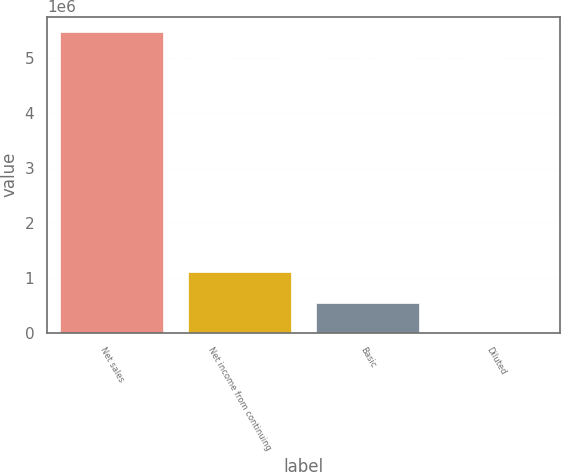Convert chart. <chart><loc_0><loc_0><loc_500><loc_500><bar_chart><fcel>Net sales<fcel>Net income from continuing<fcel>Basic<fcel>Diluted<nl><fcel>5.49086e+06<fcel>1.09817e+06<fcel>549087<fcel>0.99<nl></chart> 